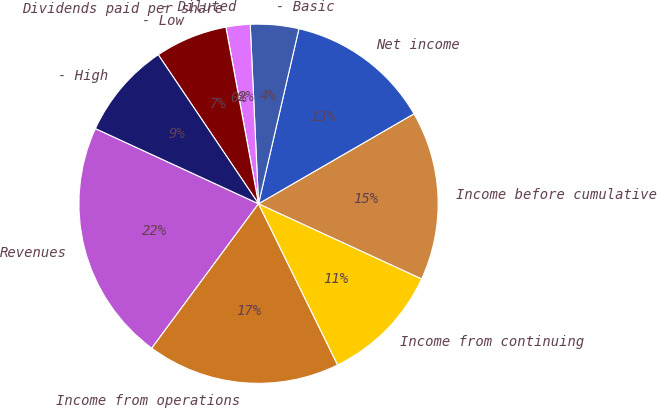<chart> <loc_0><loc_0><loc_500><loc_500><pie_chart><fcel>Revenues<fcel>Income from operations<fcel>Income from continuing<fcel>Income before cumulative<fcel>Net income<fcel>- Basic<fcel>- Diluted<fcel>Dividends paid per share<fcel>- Low<fcel>- High<nl><fcel>21.74%<fcel>17.39%<fcel>10.87%<fcel>15.22%<fcel>13.04%<fcel>4.35%<fcel>2.17%<fcel>0.0%<fcel>6.52%<fcel>8.7%<nl></chart> 